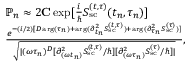<formula> <loc_0><loc_0><loc_500><loc_500>\begin{array} { r l } & { \mathbb { P } _ { n } \approx 2 { C } \exp [ { \frac { i } { } S _ { s c } ^ { ( t , \tau ) } ( t _ { n } , \tau _ { n } ) } ] } \\ & { \frac { e ^ { - ( i / 2 ) [ D \arg ( \tau _ { n } ) + \arg ( { \partial _ { t _ { n } } ^ { 2 } S _ { s c } ^ { ( t , \tau ) } } ) + \arg ( { \partial _ { \tau _ { n } } ^ { 2 } S _ { s c } ^ { ( \tau ) } } ) ] } } { \sqrt { | ( \omega \tau _ { n } ) ^ { D } [ { \partial _ { ( \omega t _ { n } ) } ^ { 2 } S _ { s c } ^ { ( t , \tau ) } } / \hbar { ] } [ { \partial _ { ( \omega \tau _ { n } ) } ^ { 2 } S _ { s c } ^ { ( \tau ) } } / \hbar { ] } | } } , } \end{array}</formula> 